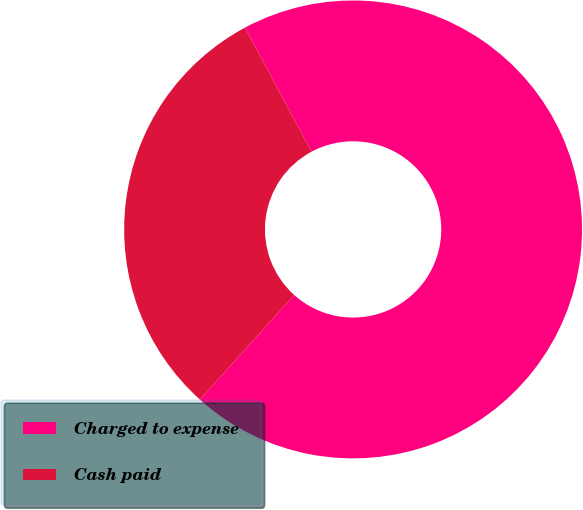<chart> <loc_0><loc_0><loc_500><loc_500><pie_chart><fcel>Charged to expense<fcel>Cash paid<nl><fcel>69.49%<fcel>30.51%<nl></chart> 